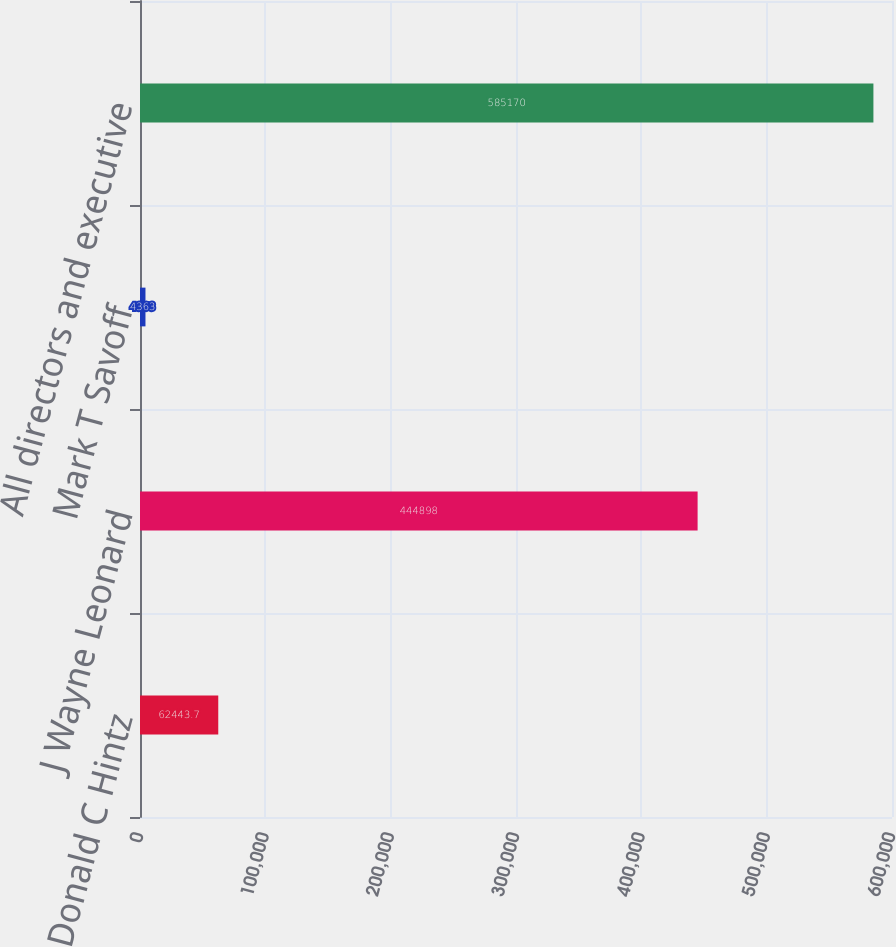Convert chart to OTSL. <chart><loc_0><loc_0><loc_500><loc_500><bar_chart><fcel>Donald C Hintz<fcel>J Wayne Leonard<fcel>Mark T Savoff<fcel>All directors and executive<nl><fcel>62443.7<fcel>444898<fcel>4363<fcel>585170<nl></chart> 